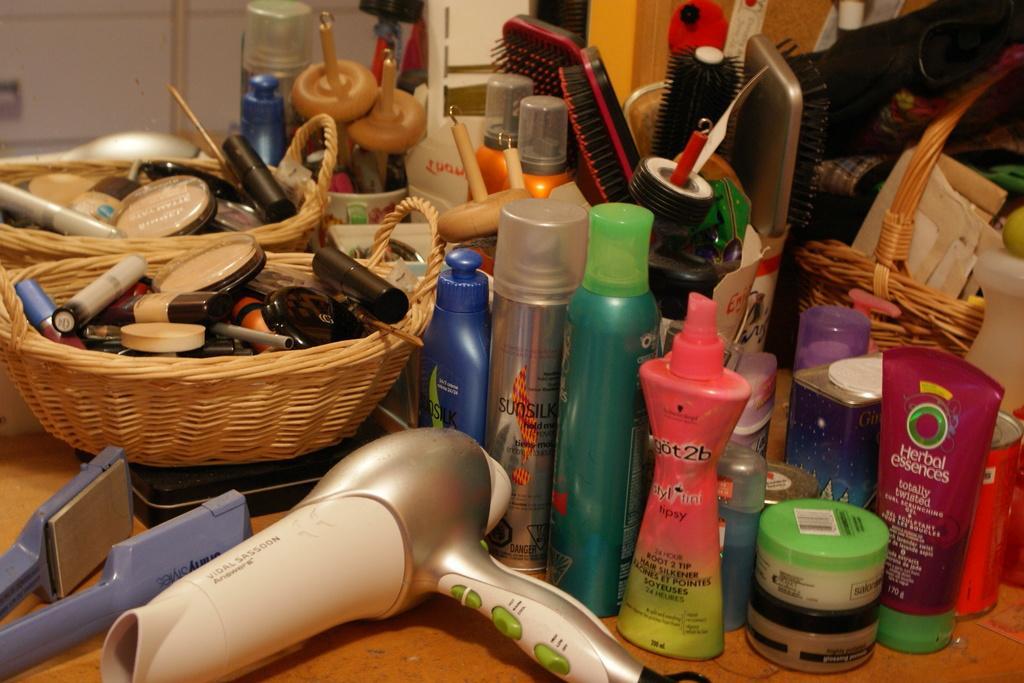<image>
Present a compact description of the photo's key features. A selection of goods with one being by the brand "Herbal essences". 